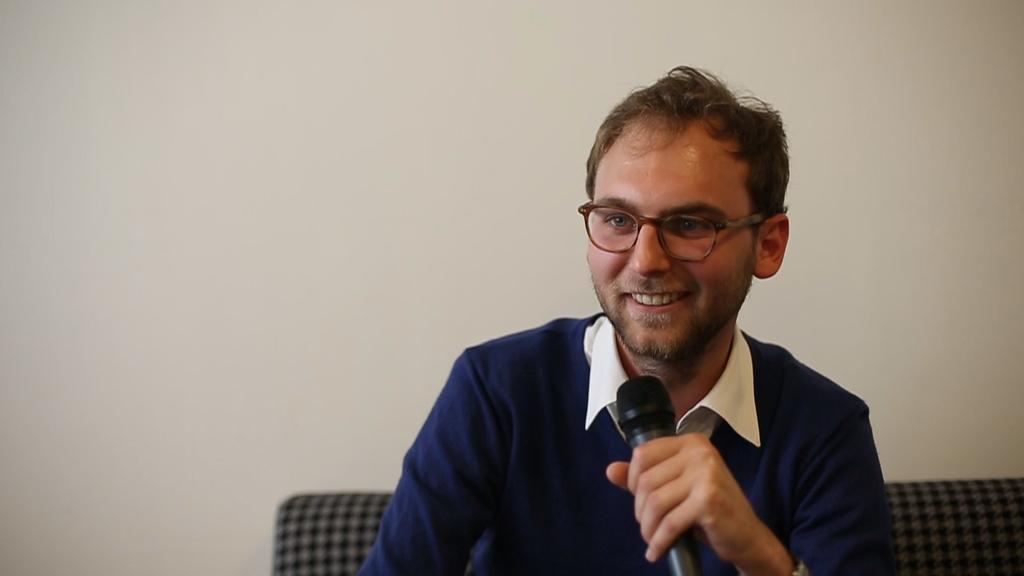What is the main subject of the image? There is a man in the image. What is the man doing in the image? The man is sitting and smiling. What object is the man holding in the image? The man is holding a microphone. What can be seen in the background of the image? There is a wall in the background of the image. What type of science experiment is the man conducting in the image? There is no science experiment present in the image; the man is simply sitting and holding a microphone. Can you see any frogs or muscles in the image? No, there are no frogs or muscles visible in the image. 